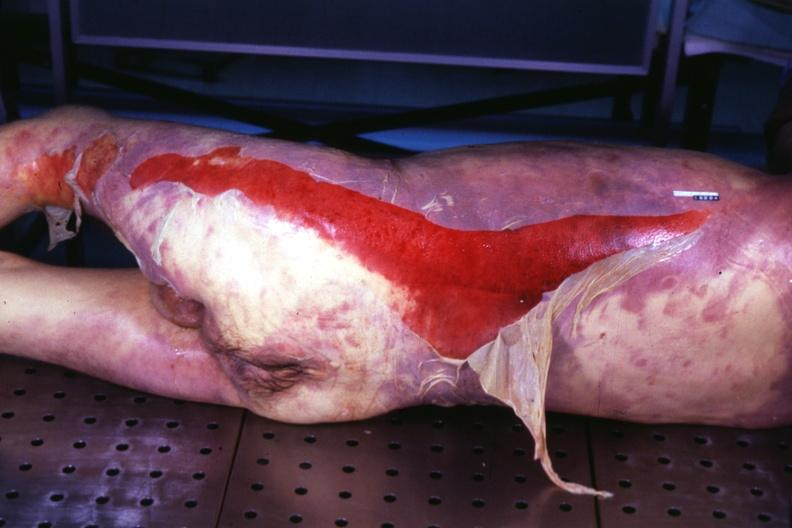does this image show body with extensive ecchymoses and desquamation?
Answer the question using a single word or phrase. Yes 